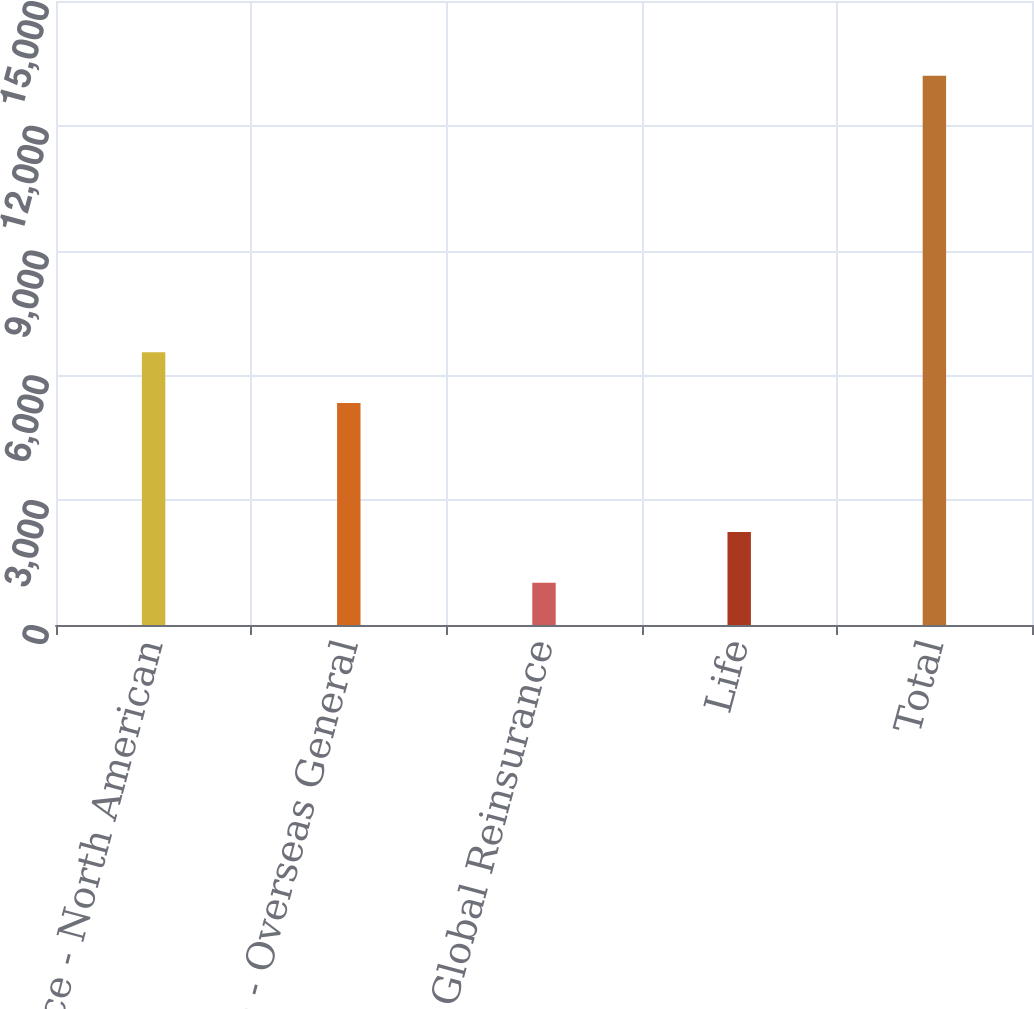Convert chart to OTSL. <chart><loc_0><loc_0><loc_500><loc_500><bar_chart><fcel>Insurance - North American<fcel>Insurance - Overseas General<fcel>Global Reinsurance<fcel>Life<fcel>Total<nl><fcel>6555.6<fcel>5337<fcel>1017<fcel>2235.6<fcel>13203<nl></chart> 